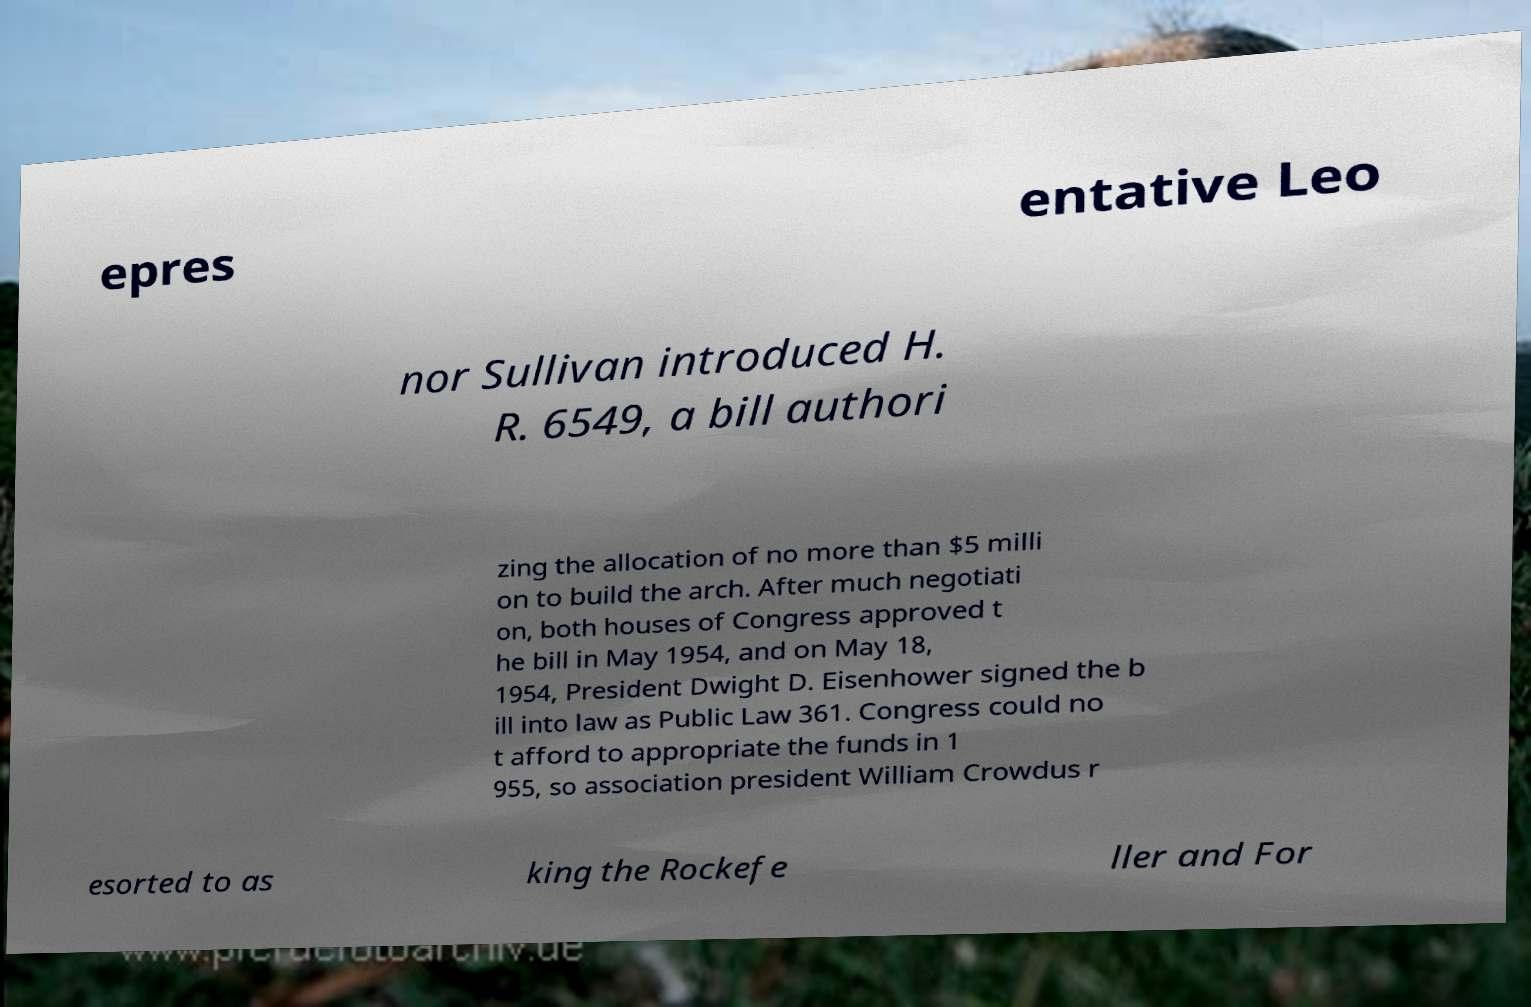For documentation purposes, I need the text within this image transcribed. Could you provide that? epres entative Leo nor Sullivan introduced H. R. 6549, a bill authori zing the allocation of no more than $5 milli on to build the arch. After much negotiati on, both houses of Congress approved t he bill in May 1954, and on May 18, 1954, President Dwight D. Eisenhower signed the b ill into law as Public Law 361. Congress could no t afford to appropriate the funds in 1 955, so association president William Crowdus r esorted to as king the Rockefe ller and For 